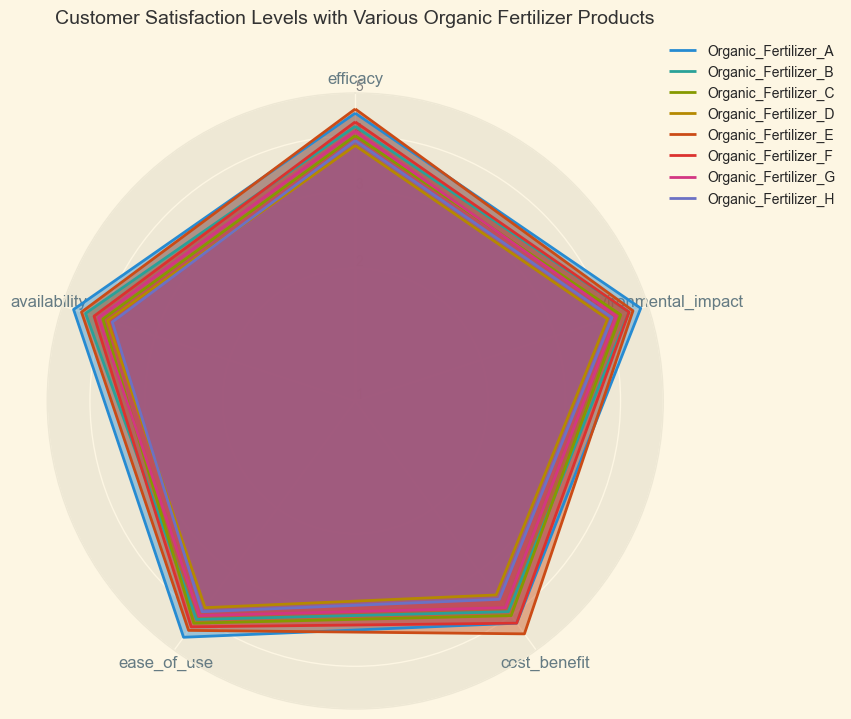Which organic fertilizer has the highest efficacy? Look at the efficacy axis on the radar chart and identify the product with the highest value plotted along this scale. Organic Fertilizer E has the highest efficacy value of 4.6.
Answer: Organic Fertilizer E Which product has the lowest cost-benefit ratio? Examine the cost-benefit axis and find the product with the smallest value plotted along this axis. Organic Fertilizer D has the lowest cost-benefit ratio with a value of 3.5.
Answer: Organic Fertilizer D What is the average environmental impact score of Organic Fertilizer A and Organic Fertilizer B? Sum the environmental impact scores for Organic Fertilizer A (4.8) and Organic Fertilizer B (4.5), then divide by 2 to find the average. (4.8 + 4.5) / 2 = 4.65.
Answer: 4.65 Between Organic Fertilizer F and Organic Fertilizer G, which one has better availability? Compare the availability scores of both fertilizers. Organic Fertilizer F has a score of 4.2 and Organic Fertilizer G has a score of 4.1; thus, Organic Fertilizer F has better availability.
Answer: Organic Fertilizer F Which two organic fertilizers have the closest scores in ease of use? Check the ease of use scores and identify the pair with the smallest difference. Organic Fertilizer C (4.2) and Organic Fertilizer E (4.4) have a difference of just 0.2, making them the closest.
Answer: Organic Fertilizer C and Organic Fertilizer E 